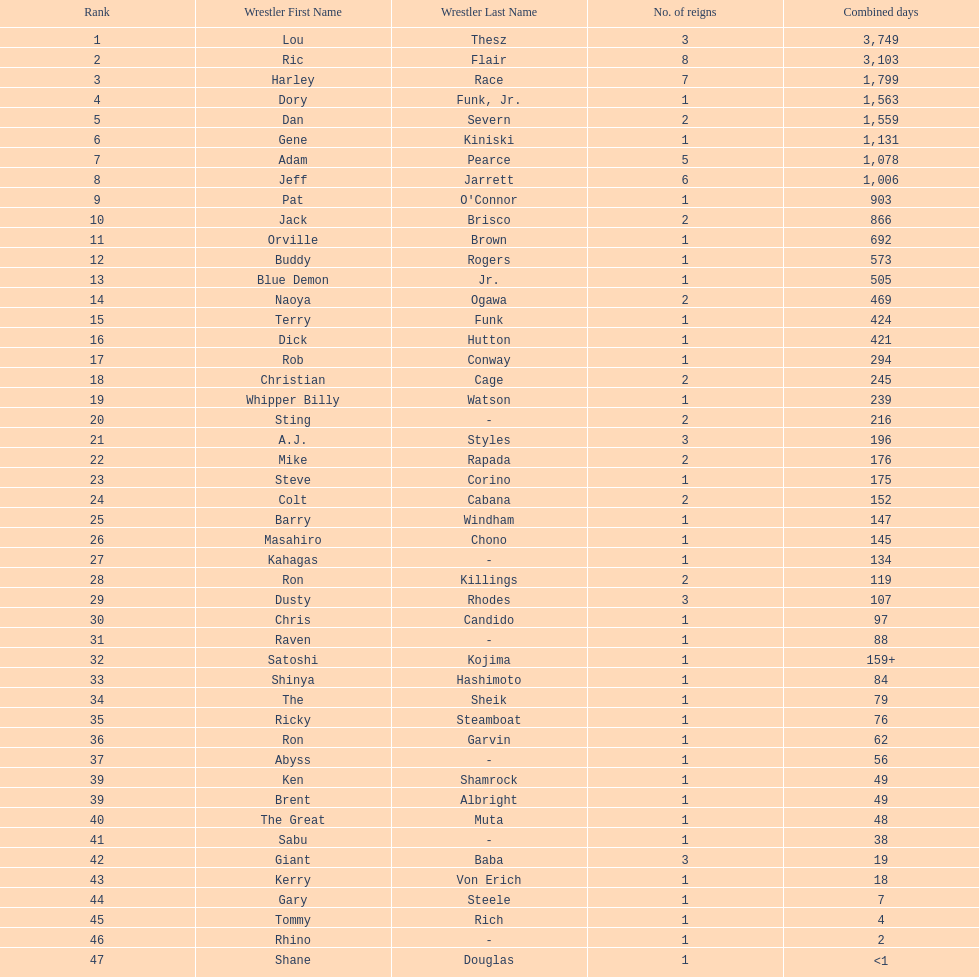Which professional wrestler has had the most number of reigns as nwa world heavyweight champion? Ric Flair. 